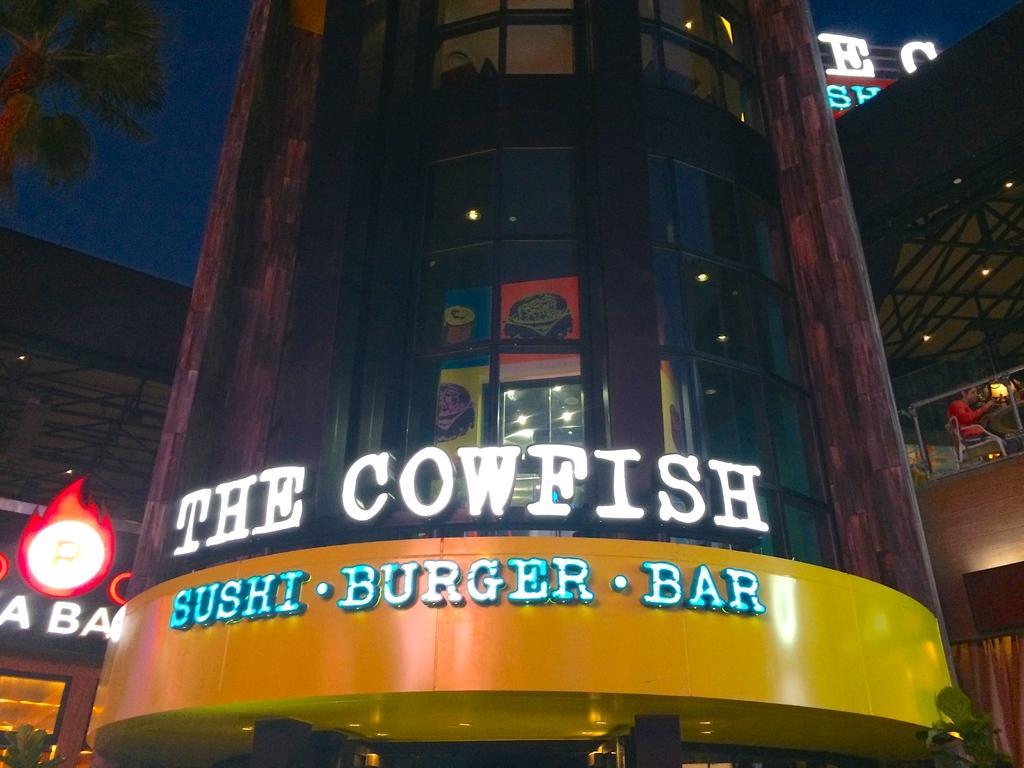Can you describe this image briefly? In this image I can see a building which is black, brown and yellow in color. In the background I can see few other buildings, a person wearing red dress is sitting on a chair, a tree and the sky. 